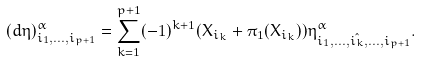Convert formula to latex. <formula><loc_0><loc_0><loc_500><loc_500>( d \eta ) ^ { \alpha } _ { i _ { 1 } , \dots , i _ { p + 1 } } = \sum _ { k = 1 } ^ { p + 1 } ( - 1 ) ^ { k + 1 } ( X _ { i _ { k } } + \pi _ { 1 } ( X _ { i _ { k } } ) ) \eta ^ { \alpha } _ { i _ { 1 } , \dots , \hat { i _ { k } } , \dots , i _ { p + 1 } } .</formula> 